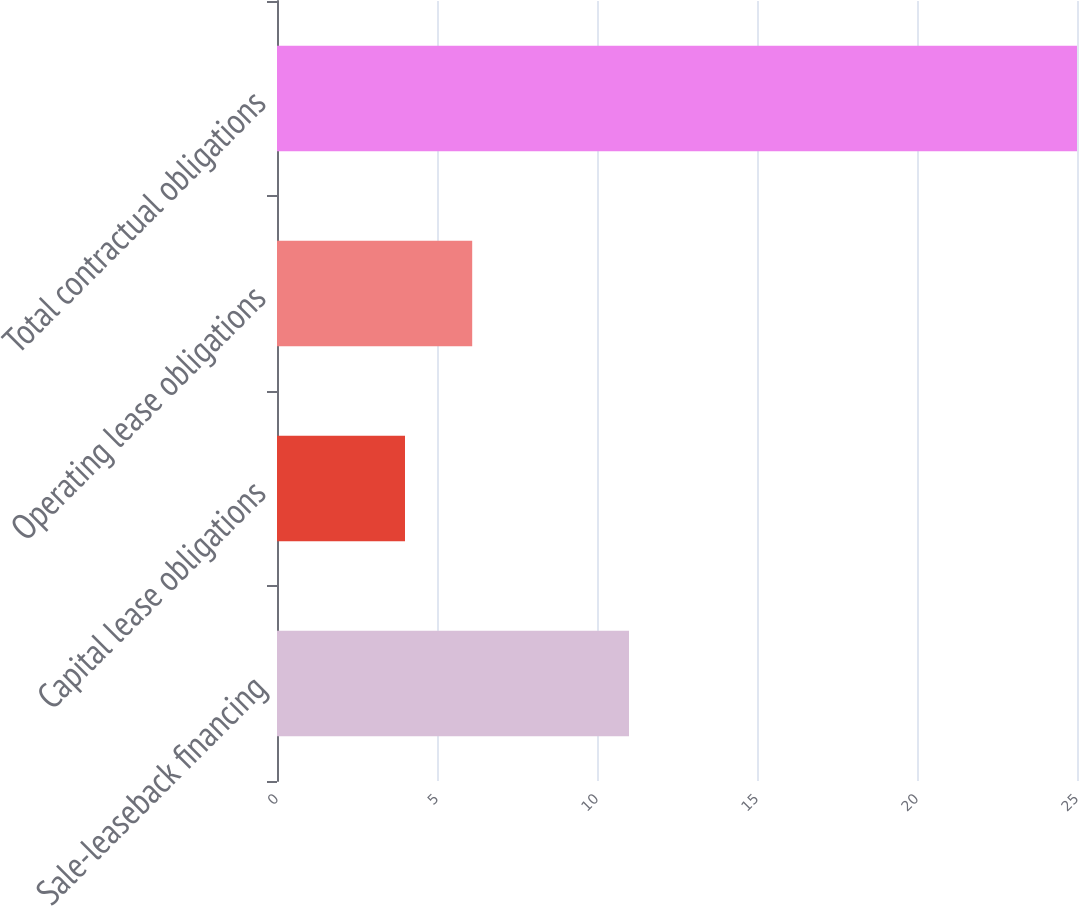<chart> <loc_0><loc_0><loc_500><loc_500><bar_chart><fcel>Sale-leaseback financing<fcel>Capital lease obligations<fcel>Operating lease obligations<fcel>Total contractual obligations<nl><fcel>11<fcel>4<fcel>6.1<fcel>25<nl></chart> 